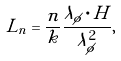<formula> <loc_0><loc_0><loc_500><loc_500>L _ { n } = \frac { n } { k } \frac { \lambda _ { \phi } \cdot H } { \lambda _ { \phi } ^ { 2 } } ,</formula> 